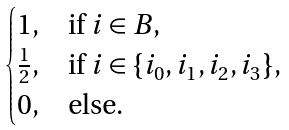<formula> <loc_0><loc_0><loc_500><loc_500>\begin{cases} 1 , & \text {if } i \in B , \\ \frac { 1 } { 2 } , & \text {if } i \in \{ i _ { 0 } , i _ { 1 } , i _ { 2 } , i _ { 3 } \} , \\ 0 , & \text {else.} \end{cases}</formula> 